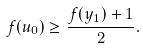<formula> <loc_0><loc_0><loc_500><loc_500>f ( u _ { 0 } ) \geq \frac { f ( y _ { 1 } ) + 1 } { 2 } .</formula> 